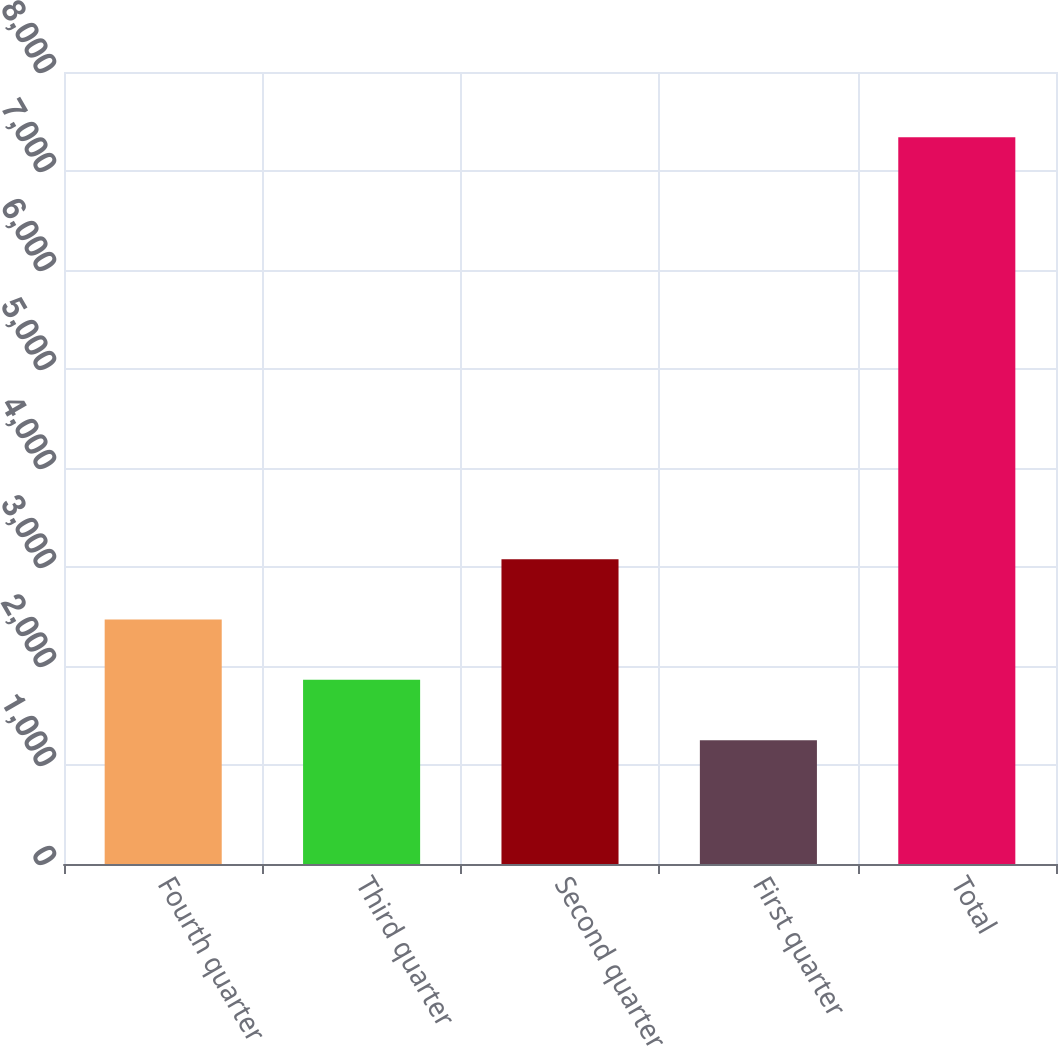<chart> <loc_0><loc_0><loc_500><loc_500><bar_chart><fcel>Fourth quarter<fcel>Third quarter<fcel>Second quarter<fcel>First quarter<fcel>Total<nl><fcel>2468.8<fcel>1859.9<fcel>3077.7<fcel>1251<fcel>7340<nl></chart> 